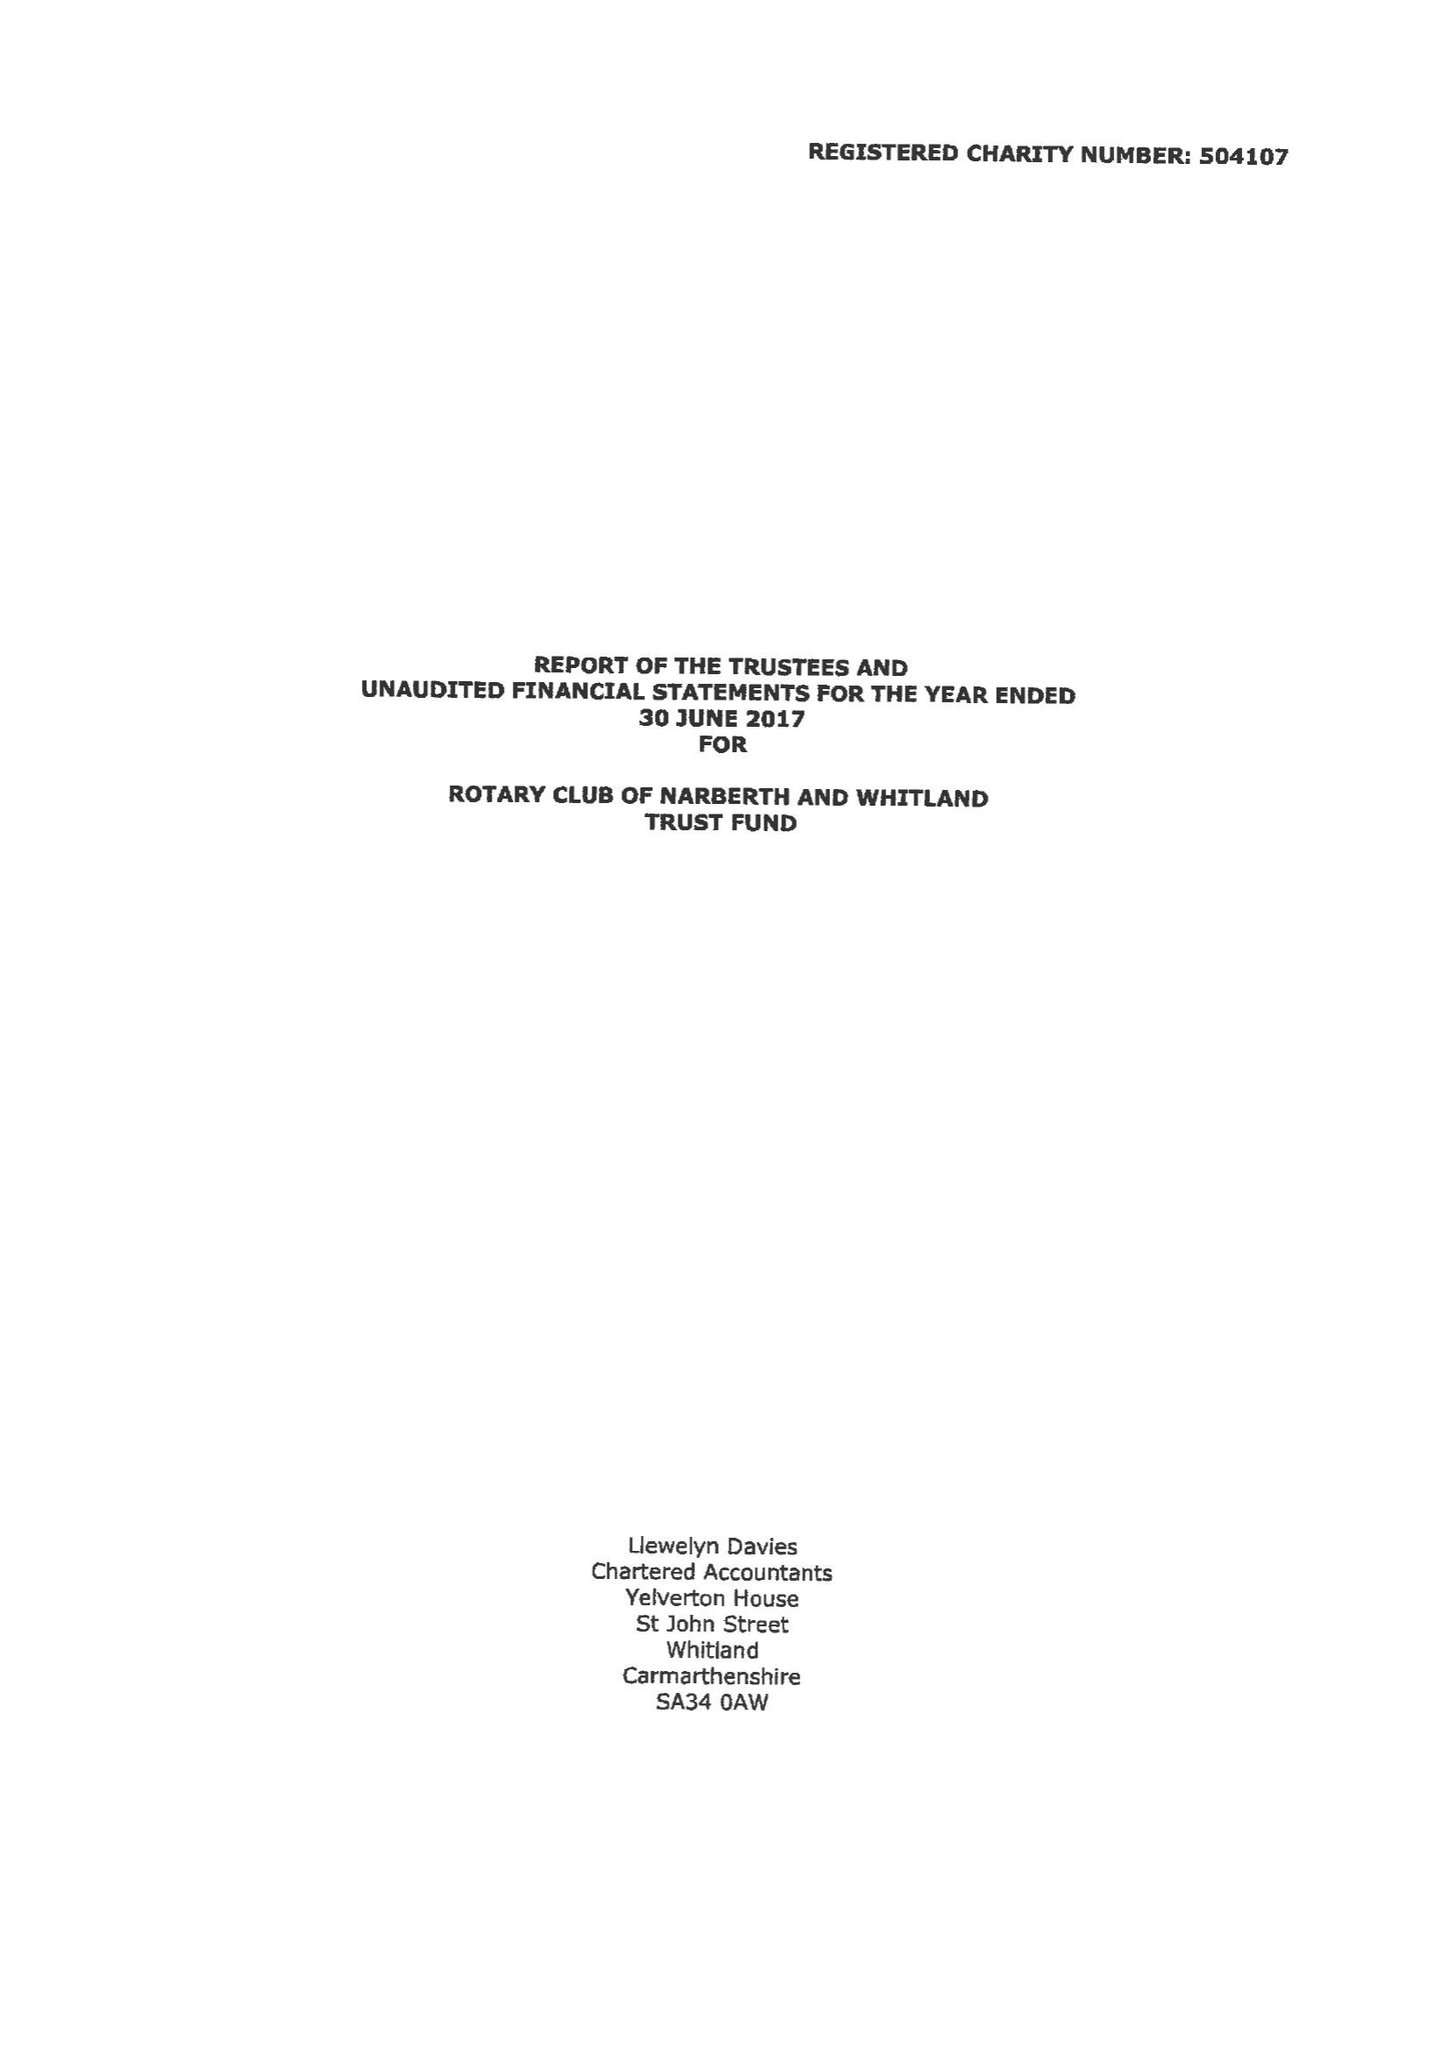What is the value for the charity_number?
Answer the question using a single word or phrase. 504107 